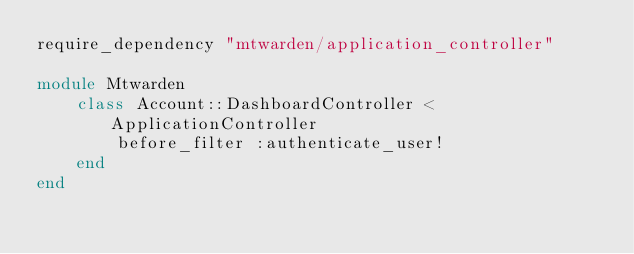Convert code to text. <code><loc_0><loc_0><loc_500><loc_500><_Ruby_>require_dependency "mtwarden/application_controller"

module Mtwarden
	class Account::DashboardController < ApplicationController
		before_filter :authenticate_user!
	end
end
</code> 